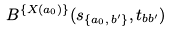<formula> <loc_0><loc_0><loc_500><loc_500>B ^ { \{ X ( a _ { 0 } ) \} } ( s _ { \{ a _ { 0 } , \, b ^ { \prime } \} } , t _ { b b ^ { \prime } } )</formula> 